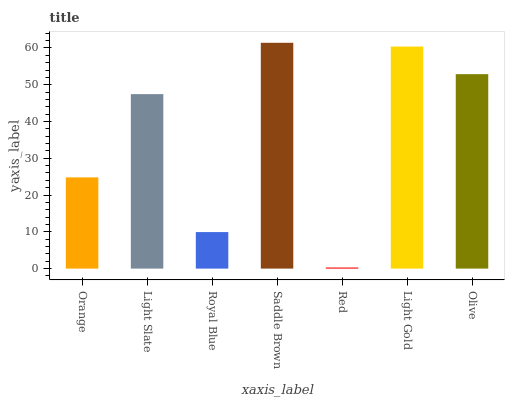Is Red the minimum?
Answer yes or no. Yes. Is Saddle Brown the maximum?
Answer yes or no. Yes. Is Light Slate the minimum?
Answer yes or no. No. Is Light Slate the maximum?
Answer yes or no. No. Is Light Slate greater than Orange?
Answer yes or no. Yes. Is Orange less than Light Slate?
Answer yes or no. Yes. Is Orange greater than Light Slate?
Answer yes or no. No. Is Light Slate less than Orange?
Answer yes or no. No. Is Light Slate the high median?
Answer yes or no. Yes. Is Light Slate the low median?
Answer yes or no. Yes. Is Saddle Brown the high median?
Answer yes or no. No. Is Orange the low median?
Answer yes or no. No. 